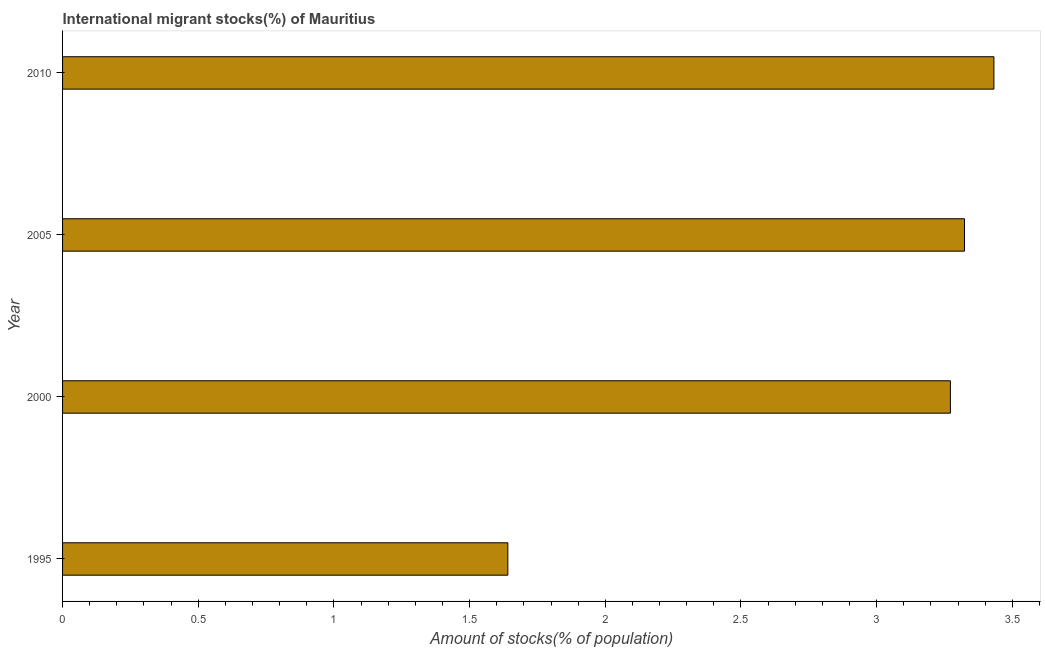Does the graph contain any zero values?
Make the answer very short. No. What is the title of the graph?
Your answer should be compact. International migrant stocks(%) of Mauritius. What is the label or title of the X-axis?
Your response must be concise. Amount of stocks(% of population). What is the label or title of the Y-axis?
Your answer should be compact. Year. What is the number of international migrant stocks in 2000?
Your answer should be very brief. 3.27. Across all years, what is the maximum number of international migrant stocks?
Your answer should be compact. 3.43. Across all years, what is the minimum number of international migrant stocks?
Offer a very short reply. 1.64. In which year was the number of international migrant stocks maximum?
Make the answer very short. 2010. In which year was the number of international migrant stocks minimum?
Your answer should be compact. 1995. What is the sum of the number of international migrant stocks?
Make the answer very short. 11.67. What is the difference between the number of international migrant stocks in 2000 and 2005?
Offer a very short reply. -0.05. What is the average number of international migrant stocks per year?
Provide a short and direct response. 2.92. What is the median number of international migrant stocks?
Ensure brevity in your answer.  3.3. What is the ratio of the number of international migrant stocks in 2000 to that in 2010?
Provide a short and direct response. 0.95. Is the difference between the number of international migrant stocks in 2000 and 2010 greater than the difference between any two years?
Give a very brief answer. No. What is the difference between the highest and the second highest number of international migrant stocks?
Provide a short and direct response. 0.11. Is the sum of the number of international migrant stocks in 1995 and 2000 greater than the maximum number of international migrant stocks across all years?
Your response must be concise. Yes. What is the difference between the highest and the lowest number of international migrant stocks?
Make the answer very short. 1.79. How many bars are there?
Provide a succinct answer. 4. How many years are there in the graph?
Your response must be concise. 4. What is the difference between two consecutive major ticks on the X-axis?
Offer a terse response. 0.5. What is the Amount of stocks(% of population) in 1995?
Make the answer very short. 1.64. What is the Amount of stocks(% of population) in 2000?
Offer a terse response. 3.27. What is the Amount of stocks(% of population) of 2005?
Offer a very short reply. 3.32. What is the Amount of stocks(% of population) of 2010?
Your answer should be compact. 3.43. What is the difference between the Amount of stocks(% of population) in 1995 and 2000?
Provide a short and direct response. -1.63. What is the difference between the Amount of stocks(% of population) in 1995 and 2005?
Keep it short and to the point. -1.68. What is the difference between the Amount of stocks(% of population) in 1995 and 2010?
Offer a terse response. -1.79. What is the difference between the Amount of stocks(% of population) in 2000 and 2005?
Give a very brief answer. -0.05. What is the difference between the Amount of stocks(% of population) in 2000 and 2010?
Your response must be concise. -0.16. What is the difference between the Amount of stocks(% of population) in 2005 and 2010?
Offer a terse response. -0.11. What is the ratio of the Amount of stocks(% of population) in 1995 to that in 2000?
Your answer should be compact. 0.5. What is the ratio of the Amount of stocks(% of population) in 1995 to that in 2005?
Your answer should be very brief. 0.49. What is the ratio of the Amount of stocks(% of population) in 1995 to that in 2010?
Offer a very short reply. 0.48. What is the ratio of the Amount of stocks(% of population) in 2000 to that in 2005?
Your response must be concise. 0.98. What is the ratio of the Amount of stocks(% of population) in 2000 to that in 2010?
Give a very brief answer. 0.95. 